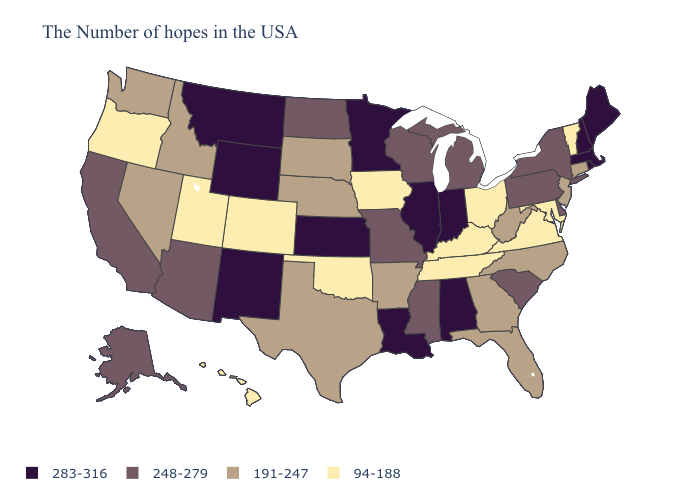What is the highest value in states that border Utah?
Short answer required. 283-316. Name the states that have a value in the range 94-188?
Answer briefly. Vermont, Maryland, Virginia, Ohio, Kentucky, Tennessee, Iowa, Oklahoma, Colorado, Utah, Oregon, Hawaii. Name the states that have a value in the range 248-279?
Write a very short answer. New York, Delaware, Pennsylvania, South Carolina, Michigan, Wisconsin, Mississippi, Missouri, North Dakota, Arizona, California, Alaska. What is the lowest value in the USA?
Short answer required. 94-188. Among the states that border Pennsylvania , which have the lowest value?
Answer briefly. Maryland, Ohio. Among the states that border North Dakota , does South Dakota have the lowest value?
Keep it brief. Yes. What is the value of Iowa?
Give a very brief answer. 94-188. What is the value of Alabama?
Write a very short answer. 283-316. What is the value of Indiana?
Give a very brief answer. 283-316. What is the value of New York?
Concise answer only. 248-279. Name the states that have a value in the range 283-316?
Concise answer only. Maine, Massachusetts, Rhode Island, New Hampshire, Indiana, Alabama, Illinois, Louisiana, Minnesota, Kansas, Wyoming, New Mexico, Montana. Name the states that have a value in the range 248-279?
Quick response, please. New York, Delaware, Pennsylvania, South Carolina, Michigan, Wisconsin, Mississippi, Missouri, North Dakota, Arizona, California, Alaska. Which states have the lowest value in the MidWest?
Write a very short answer. Ohio, Iowa. Name the states that have a value in the range 248-279?
Answer briefly. New York, Delaware, Pennsylvania, South Carolina, Michigan, Wisconsin, Mississippi, Missouri, North Dakota, Arizona, California, Alaska. Which states have the highest value in the USA?
Keep it brief. Maine, Massachusetts, Rhode Island, New Hampshire, Indiana, Alabama, Illinois, Louisiana, Minnesota, Kansas, Wyoming, New Mexico, Montana. 